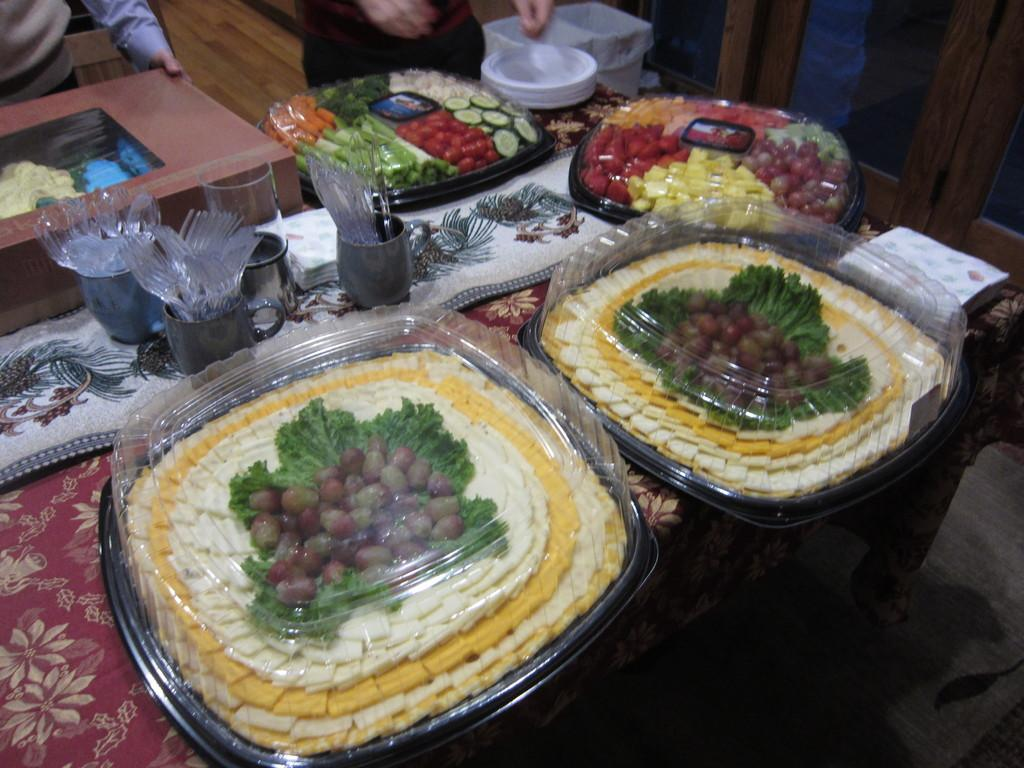What is on the plates in the image? There are food items on plates in the image. Who are these food items intended for? The food items are for kids. What utensils are available on the table? There are forks, spoons, and knives on the table. Can you describe the people in the background of the image? There are two persons in the background of the image. What else can be seen in the background of the image? There are plates in the background of the image. What historical event is being commemorated by the line of fans in the image? There is no line of fans or any reference to a historical event in the image. 